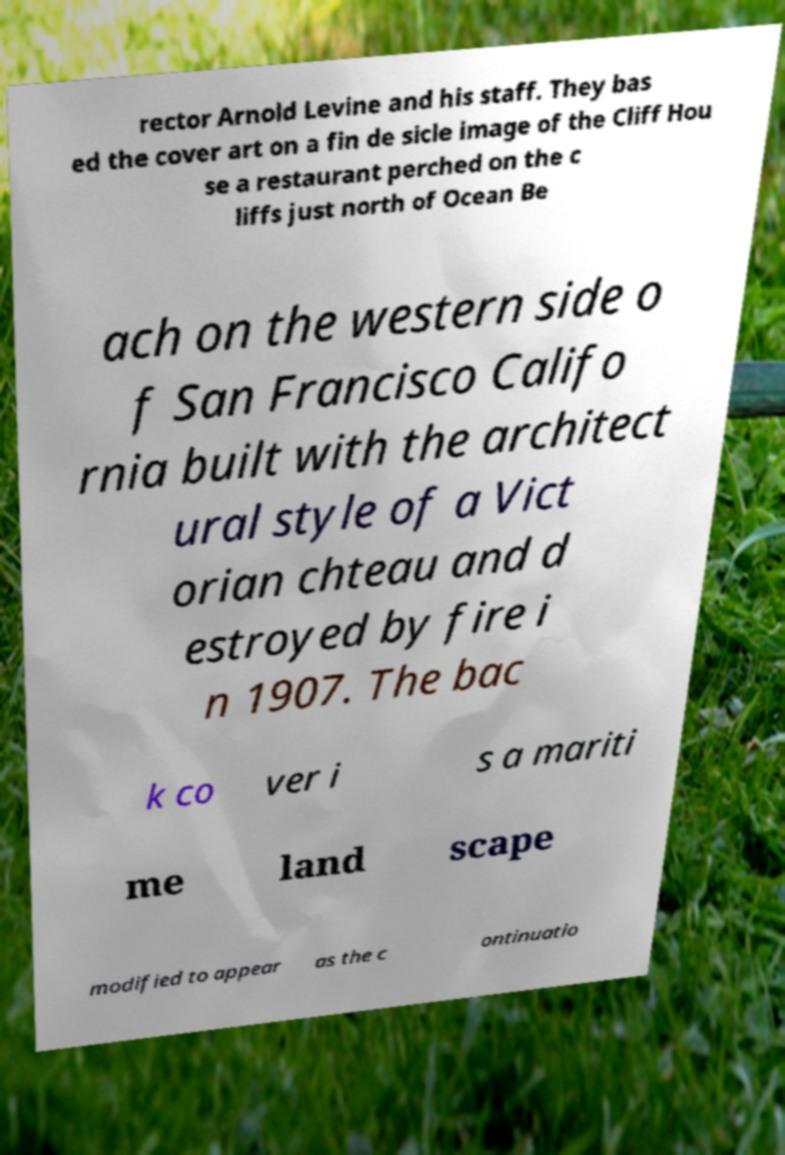Please read and relay the text visible in this image. What does it say? rector Arnold Levine and his staff. They bas ed the cover art on a fin de sicle image of the Cliff Hou se a restaurant perched on the c liffs just north of Ocean Be ach on the western side o f San Francisco Califo rnia built with the architect ural style of a Vict orian chteau and d estroyed by fire i n 1907. The bac k co ver i s a mariti me land scape modified to appear as the c ontinuatio 